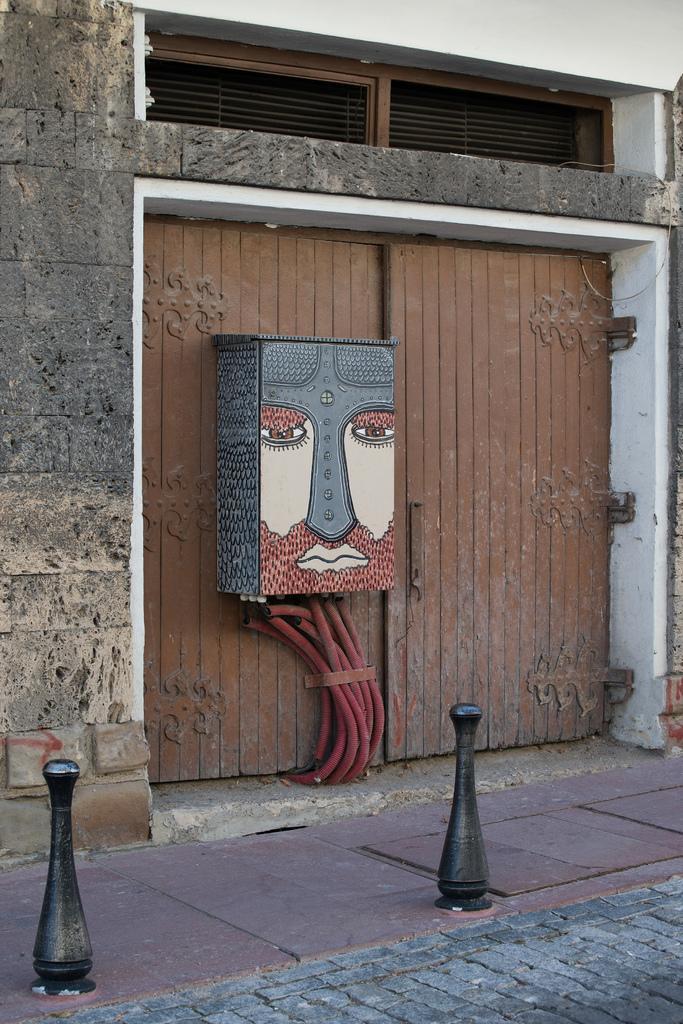Could you give a brief overview of what you see in this image? In this picture I can see a wooden door and I can see a wooden box fixed to the door and I can see wall and it looks like a building. 